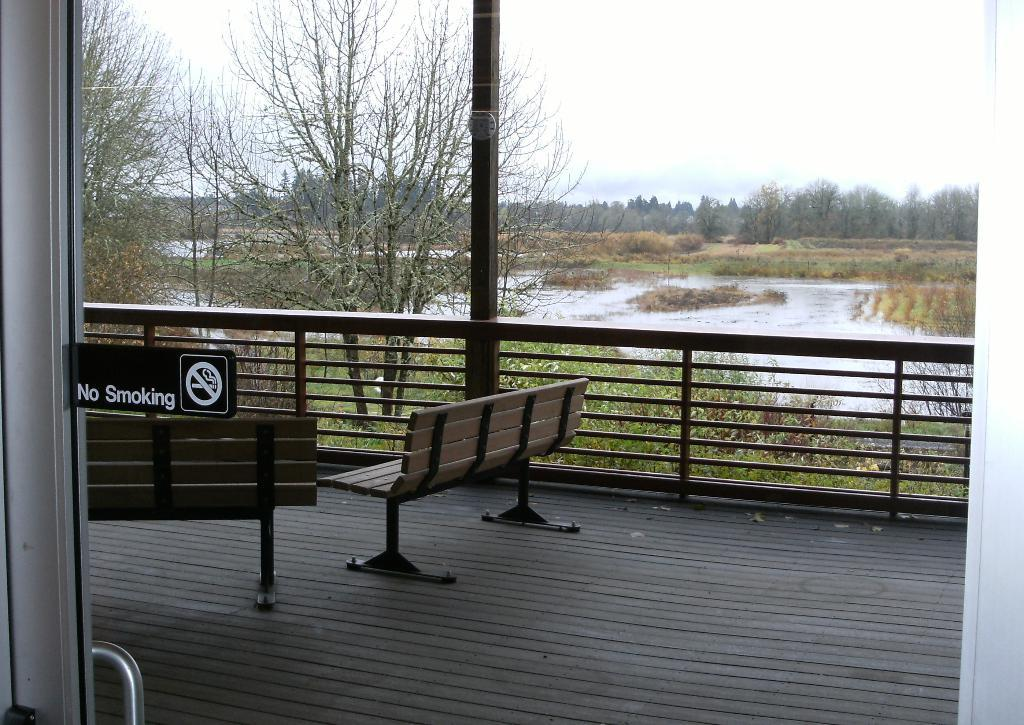What is the main object in the image? There is a board in the image. What is on the surface of the board? There are benches on the surface of the board. What can be seen in the background of the image? There is a fence, trees, plants, water, and the sky visible in the background of the image. What type of crook is trying to break the rule in the image? There is no crook or rule present in the image; it features a board with benches and a background with a fence, trees, plants, water, and the sky. Can you tell me the name of the judge who is presiding over the case in the image? There is no case or judge present in the image; it features a board with benches and a background with a fence, trees, plants, water, and the sky. 